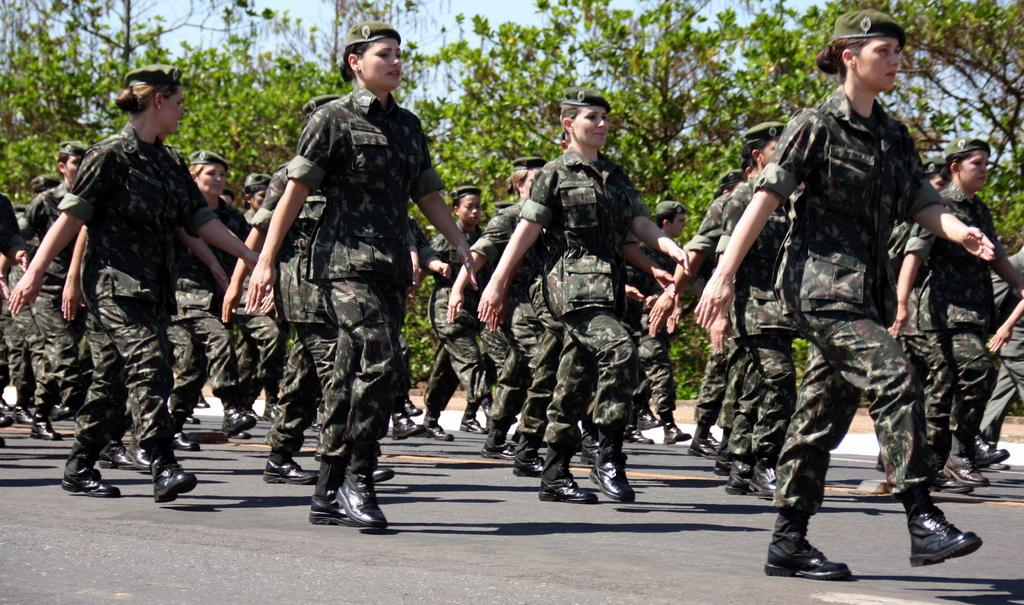What is happening in the image involving a group of people? The people are marching on the road in the image. What can be seen in the background of the image? There are trees and the sky visible in the image. What type of surface are the people marching on? The people are marching on a road in the image. What is visible beneath the people's feet? The ground is visible in the image. What type of machine can be seen on the side of the road in the image? There is no machine visible on the side of the road in the image. Where is the desk located in the image? There is no desk present in the image. 